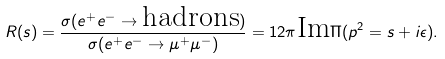Convert formula to latex. <formula><loc_0><loc_0><loc_500><loc_500>R ( s ) = \frac { \sigma ( e ^ { + } e ^ { - } \to \text {hadrons} ) } { \sigma ( e ^ { + } e ^ { - } \to \mu ^ { + } \mu ^ { - } ) } = 1 2 \pi \text {Im} \Pi ( p ^ { 2 } = s + i \epsilon ) .</formula> 